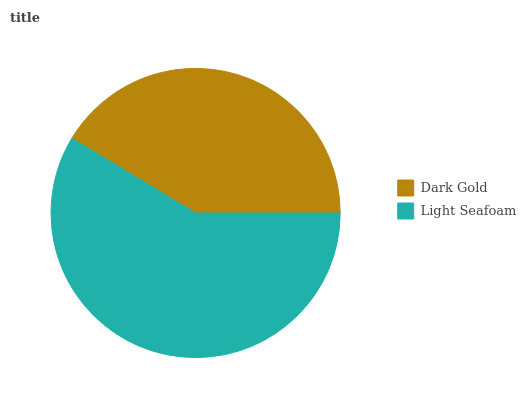Is Dark Gold the minimum?
Answer yes or no. Yes. Is Light Seafoam the maximum?
Answer yes or no. Yes. Is Light Seafoam the minimum?
Answer yes or no. No. Is Light Seafoam greater than Dark Gold?
Answer yes or no. Yes. Is Dark Gold less than Light Seafoam?
Answer yes or no. Yes. Is Dark Gold greater than Light Seafoam?
Answer yes or no. No. Is Light Seafoam less than Dark Gold?
Answer yes or no. No. Is Light Seafoam the high median?
Answer yes or no. Yes. Is Dark Gold the low median?
Answer yes or no. Yes. Is Dark Gold the high median?
Answer yes or no. No. Is Light Seafoam the low median?
Answer yes or no. No. 